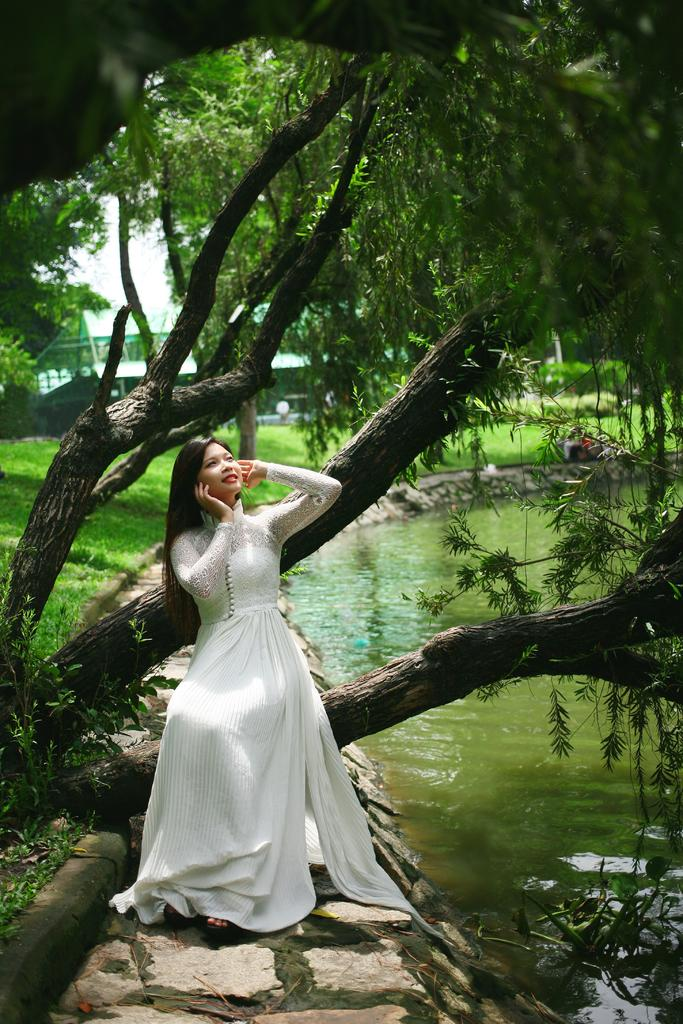Who is the main subject in the image? There is a woman in the image. What is the woman wearing? The woman is wearing a white dress. Where is the woman positioned in the image? The woman is standing in the front of the image. What can be seen in the background of the image? There is a tree and a small pond with water in the background of the image. What type of marble is being advertised in the image? There is no marble or advertisement present in the image; it features a woman standing in front of a tree and a small pond. 